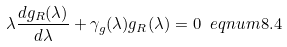Convert formula to latex. <formula><loc_0><loc_0><loc_500><loc_500>\lambda \frac { d g _ { R } ( \lambda ) } { d \lambda } + \gamma _ { g } ( \lambda ) g _ { R } ( \lambda ) = 0 \ e q n u m { 8 . 4 }</formula> 